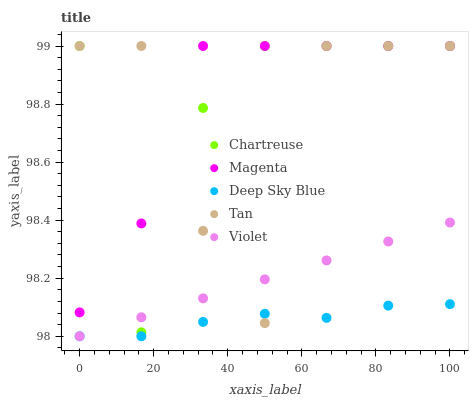Does Deep Sky Blue have the minimum area under the curve?
Answer yes or no. Yes. Does Magenta have the maximum area under the curve?
Answer yes or no. Yes. Does Tan have the minimum area under the curve?
Answer yes or no. No. Does Tan have the maximum area under the curve?
Answer yes or no. No. Is Violet the smoothest?
Answer yes or no. Yes. Is Tan the roughest?
Answer yes or no. Yes. Is Magenta the smoothest?
Answer yes or no. No. Is Magenta the roughest?
Answer yes or no. No. Does Deep Sky Blue have the lowest value?
Answer yes or no. Yes. Does Tan have the lowest value?
Answer yes or no. No. Does Magenta have the highest value?
Answer yes or no. Yes. Does Deep Sky Blue have the highest value?
Answer yes or no. No. Is Deep Sky Blue less than Chartreuse?
Answer yes or no. Yes. Is Magenta greater than Deep Sky Blue?
Answer yes or no. Yes. Does Magenta intersect Chartreuse?
Answer yes or no. Yes. Is Magenta less than Chartreuse?
Answer yes or no. No. Is Magenta greater than Chartreuse?
Answer yes or no. No. Does Deep Sky Blue intersect Chartreuse?
Answer yes or no. No. 